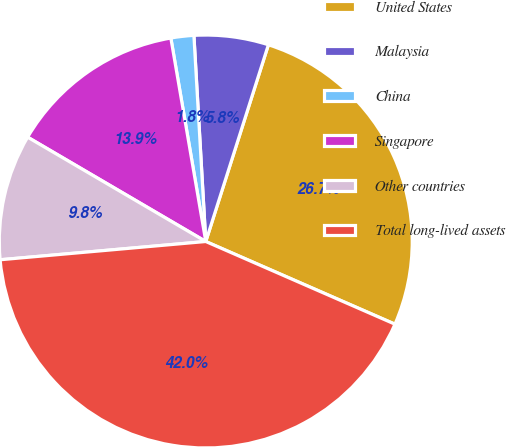<chart> <loc_0><loc_0><loc_500><loc_500><pie_chart><fcel>United States<fcel>Malaysia<fcel>China<fcel>Singapore<fcel>Other countries<fcel>Total long-lived assets<nl><fcel>26.65%<fcel>5.82%<fcel>1.79%<fcel>13.86%<fcel>9.84%<fcel>42.03%<nl></chart> 